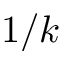Convert formula to latex. <formula><loc_0><loc_0><loc_500><loc_500>1 / k</formula> 